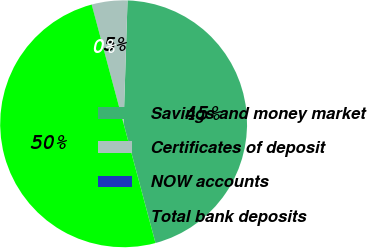Convert chart to OTSL. <chart><loc_0><loc_0><loc_500><loc_500><pie_chart><fcel>Savings and money market<fcel>Certificates of deposit<fcel>NOW accounts<fcel>Total bank deposits<nl><fcel>45.34%<fcel>4.66%<fcel>0.01%<fcel>49.99%<nl></chart> 